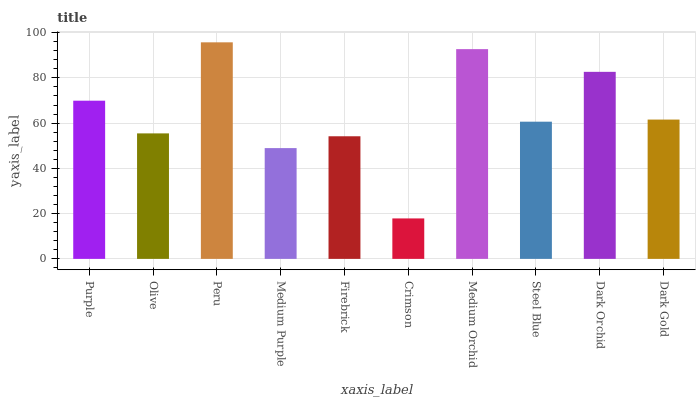Is Crimson the minimum?
Answer yes or no. Yes. Is Peru the maximum?
Answer yes or no. Yes. Is Olive the minimum?
Answer yes or no. No. Is Olive the maximum?
Answer yes or no. No. Is Purple greater than Olive?
Answer yes or no. Yes. Is Olive less than Purple?
Answer yes or no. Yes. Is Olive greater than Purple?
Answer yes or no. No. Is Purple less than Olive?
Answer yes or no. No. Is Dark Gold the high median?
Answer yes or no. Yes. Is Steel Blue the low median?
Answer yes or no. Yes. Is Crimson the high median?
Answer yes or no. No. Is Purple the low median?
Answer yes or no. No. 